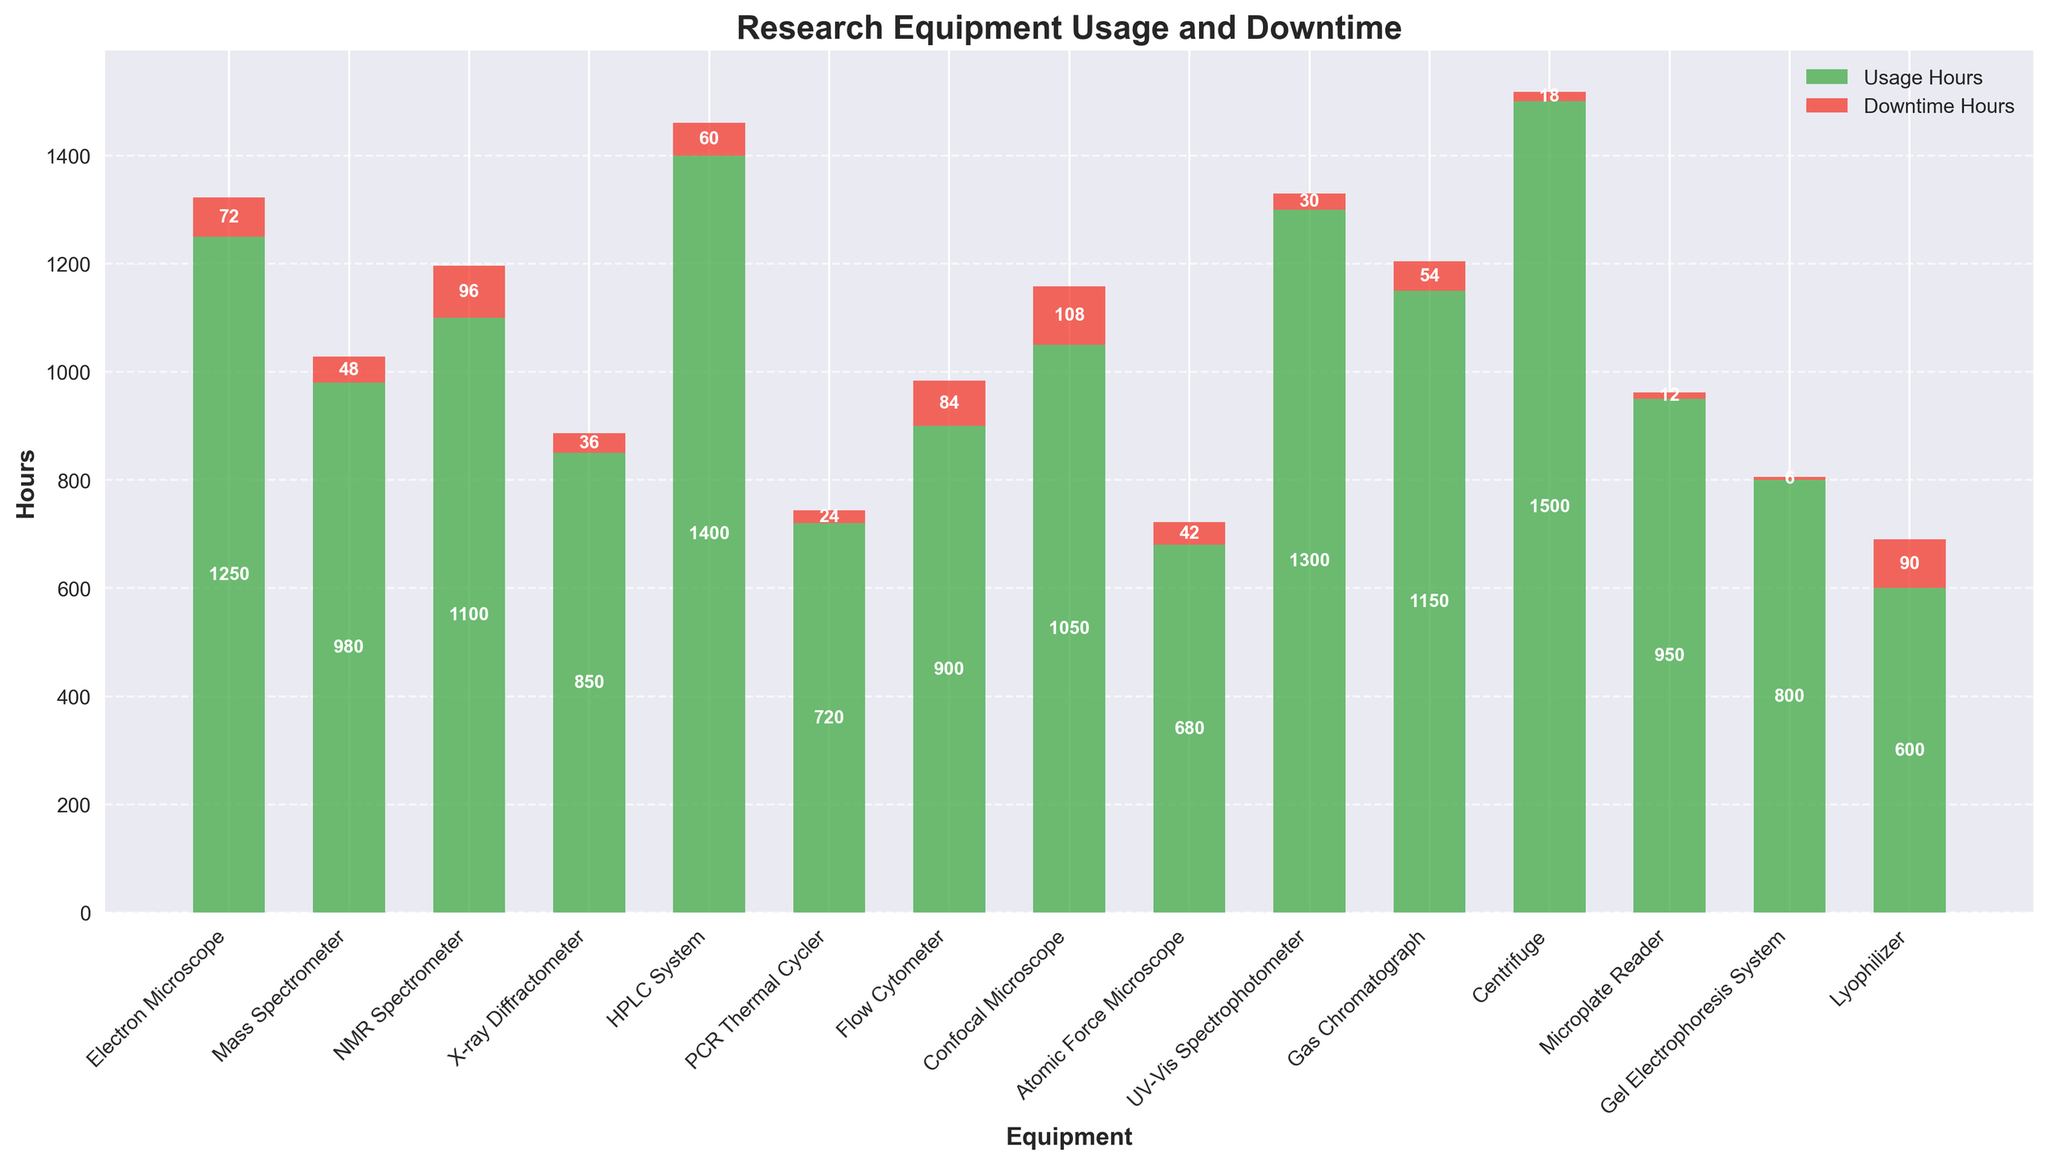Which equipment has the highest usage hours? By looking at the height of the green bars representing "Usage Hours," the Centrifuge has the highest value.
Answer: Centrifuge What is the combined downtime hours for the NMR Spectrometer and the Confocal Microscope? Sum the downtime hours for NMR Spectrometer (96 hours) and Confocal Microscope (108 hours): 96 + 108.
Answer: 204 Which equipment has the least downtime hours? By looking at the height of the red bars representing "Downtime Hours," the Gel Electrophoresis System has the lowest value.
Answer: Gel Electrophoresis System How much more is the usage hours of the HPLC System compared to the Atomic Force Microscope? Subtract the usage hours of the Atomic Force Microscope (680) from HPLC System (1400): 1400 - 680.
Answer: 720 What is the average usage hours of all equipment? Sum all usage hours (1250 + 980 + 1100 + 850 + 1400 + 720 + 900 + 1050 + 680 + 1300 + 1150 + 1500 + 950 + 800 + 600 = 15230), then divide by the number of equipment (15): 15230 / 15.
Answer: 1015.33 Which equipment has more downtime hours: the Mass Spectrometer or the Flow Cytometer? Compare the red bars of the Mass Spectrometer (48 hours) and the Flow Cytometer (84 hours).
Answer: Flow Cytometer What is the total usage hours for all microscopes (Electron Microscope, Confocal Microscope, Atomic Force Microscope)? Sum the usage hours of Electron Microscope (1250), Confocal Microscope (1050), and Atomic Force Microscope (680): 1250 + 1050 + 680.
Answer: 2980 Does the Lyophilizer have more downtime hours than usage hours? Compare the height of the red and green bars for the Lyophilizer (90 downtime hours and 600 usage hours).
Answer: No How many equipment types have downtime hours exceeding 50 hours? Count the number of equipment where the red bars are taller than 50 units: NMR Spectrometer, Flow Cytometer, Confocal Microscope, Lyophilizer, and Gas Chromatograph.
Answer: 5 Which equipment is used more: the Mass Spectrometer or the UV-Vis Spectrophotometer? Compare the height of the green bars for the Mass Spectrometer (980 hours) and the UV-Vis Spectrophotometer (1300 hours).
Answer: UV-Vis Spectrophotometer 